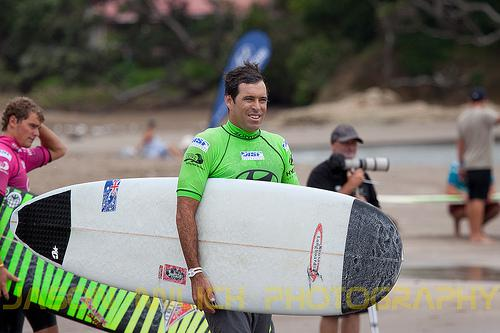Question: where was the picture taken?
Choices:
A. At the beach.
B. At the home.
C. At the church.
D. At the hospital.
Answer with the letter. Answer: A Question: what color is the man's shirt?
Choices:
A. The shirt is green.
B. Yellow.
C. White.
D. Black.
Answer with the letter. Answer: A Question: what are they standing on?
Choices:
A. Gravel.
B. Wood.
C. Grass.
D. The sand.
Answer with the letter. Answer: D Question: who is carrying the camera?
Choices:
A. The man in the black shirt.
B. The woman.
C. The girl.
D. The boy.
Answer with the letter. Answer: A 